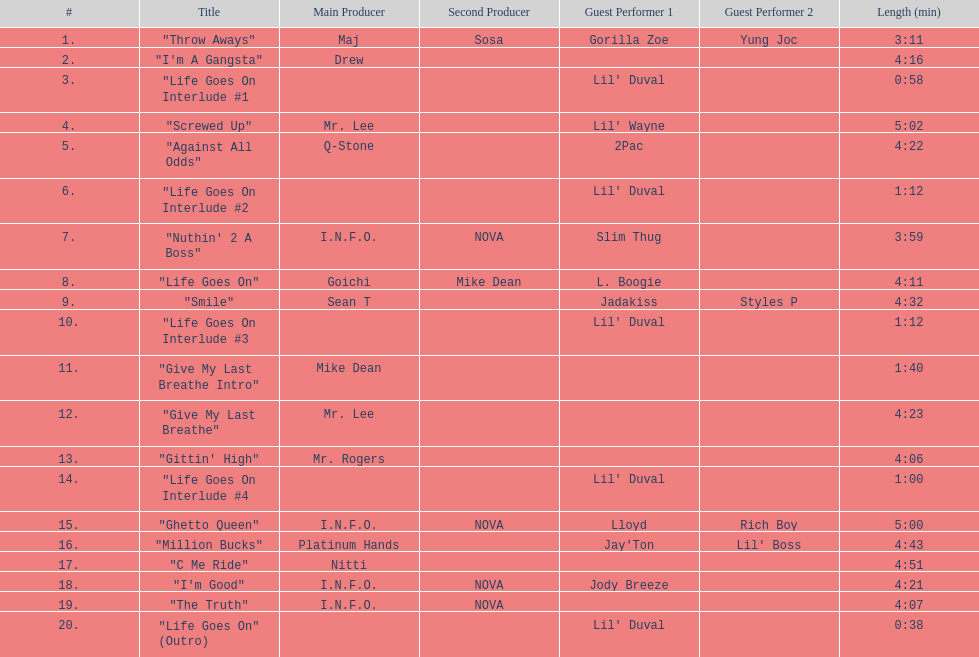What is the number of tracks featuring 2pac? 1. 